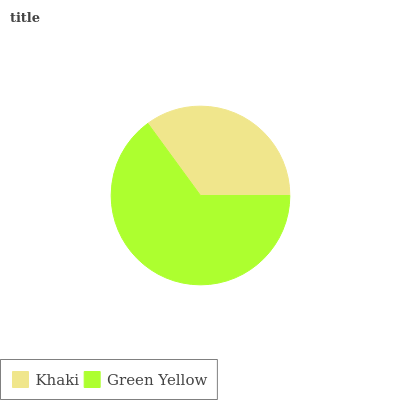Is Khaki the minimum?
Answer yes or no. Yes. Is Green Yellow the maximum?
Answer yes or no. Yes. Is Green Yellow the minimum?
Answer yes or no. No. Is Green Yellow greater than Khaki?
Answer yes or no. Yes. Is Khaki less than Green Yellow?
Answer yes or no. Yes. Is Khaki greater than Green Yellow?
Answer yes or no. No. Is Green Yellow less than Khaki?
Answer yes or no. No. Is Green Yellow the high median?
Answer yes or no. Yes. Is Khaki the low median?
Answer yes or no. Yes. Is Khaki the high median?
Answer yes or no. No. Is Green Yellow the low median?
Answer yes or no. No. 